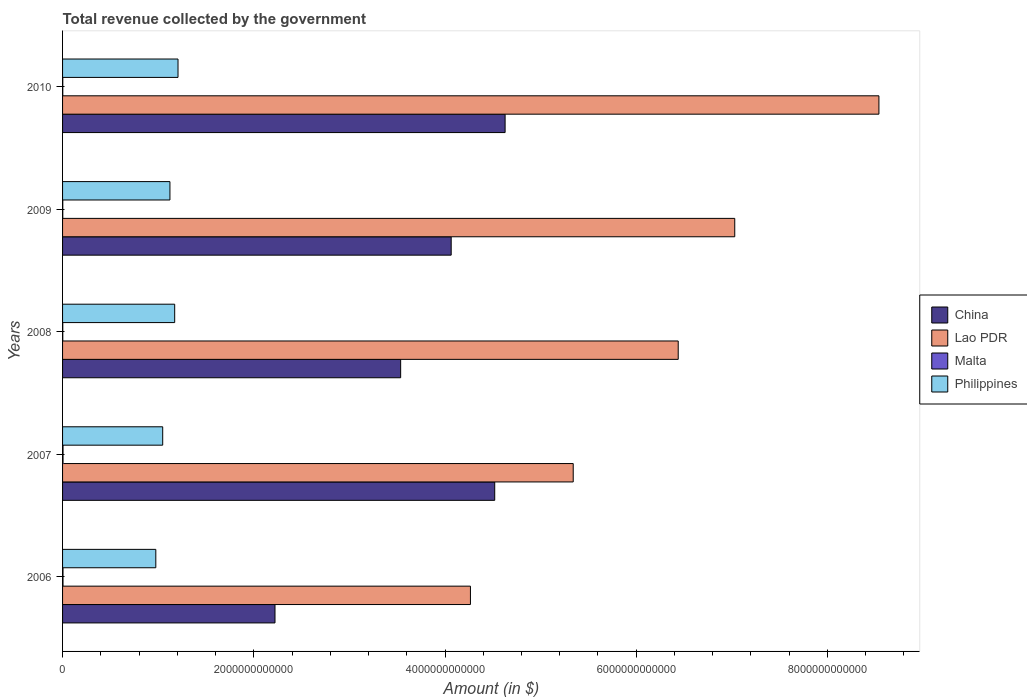How many different coloured bars are there?
Offer a very short reply. 4. How many groups of bars are there?
Offer a very short reply. 5. Are the number of bars on each tick of the Y-axis equal?
Provide a succinct answer. Yes. How many bars are there on the 2nd tick from the bottom?
Your answer should be compact. 4. What is the label of the 4th group of bars from the top?
Offer a terse response. 2007. What is the total revenue collected by the government in Philippines in 2007?
Give a very brief answer. 1.05e+12. Across all years, what is the maximum total revenue collected by the government in Lao PDR?
Ensure brevity in your answer.  8.54e+12. Across all years, what is the minimum total revenue collected by the government in Lao PDR?
Offer a very short reply. 4.27e+12. In which year was the total revenue collected by the government in Lao PDR maximum?
Provide a succinct answer. 2010. In which year was the total revenue collected by the government in Lao PDR minimum?
Make the answer very short. 2006. What is the total total revenue collected by the government in Philippines in the graph?
Your response must be concise. 5.53e+12. What is the difference between the total revenue collected by the government in Philippines in 2008 and that in 2010?
Offer a very short reply. -3.49e+1. What is the difference between the total revenue collected by the government in Malta in 2010 and the total revenue collected by the government in China in 2007?
Your response must be concise. -4.52e+12. What is the average total revenue collected by the government in Malta per year?
Provide a short and direct response. 3.25e+09. In the year 2007, what is the difference between the total revenue collected by the government in Malta and total revenue collected by the government in Lao PDR?
Ensure brevity in your answer.  -5.34e+12. What is the ratio of the total revenue collected by the government in Philippines in 2006 to that in 2007?
Provide a succinct answer. 0.93. What is the difference between the highest and the second highest total revenue collected by the government in China?
Ensure brevity in your answer.  1.09e+11. What is the difference between the highest and the lowest total revenue collected by the government in Malta?
Keep it short and to the point. 2.70e+09. Is the sum of the total revenue collected by the government in Philippines in 2007 and 2008 greater than the maximum total revenue collected by the government in China across all years?
Make the answer very short. No. Is it the case that in every year, the sum of the total revenue collected by the government in Malta and total revenue collected by the government in China is greater than the sum of total revenue collected by the government in Philippines and total revenue collected by the government in Lao PDR?
Make the answer very short. No. What does the 4th bar from the top in 2009 represents?
Give a very brief answer. China. What does the 3rd bar from the bottom in 2009 represents?
Keep it short and to the point. Malta. Is it the case that in every year, the sum of the total revenue collected by the government in Malta and total revenue collected by the government in China is greater than the total revenue collected by the government in Lao PDR?
Your answer should be compact. No. How many bars are there?
Give a very brief answer. 20. How many years are there in the graph?
Provide a short and direct response. 5. What is the difference between two consecutive major ticks on the X-axis?
Your answer should be very brief. 2.00e+12. Are the values on the major ticks of X-axis written in scientific E-notation?
Offer a terse response. No. Does the graph contain any zero values?
Give a very brief answer. No. Does the graph contain grids?
Your answer should be very brief. No. Where does the legend appear in the graph?
Offer a terse response. Center right. What is the title of the graph?
Offer a terse response. Total revenue collected by the government. What is the label or title of the X-axis?
Your response must be concise. Amount (in $). What is the label or title of the Y-axis?
Provide a succinct answer. Years. What is the Amount (in $) in China in 2006?
Your response must be concise. 2.22e+12. What is the Amount (in $) of Lao PDR in 2006?
Offer a terse response. 4.27e+12. What is the Amount (in $) in Malta in 2006?
Your response must be concise. 4.51e+09. What is the Amount (in $) of Philippines in 2006?
Your response must be concise. 9.75e+11. What is the Amount (in $) of China in 2007?
Your answer should be very brief. 4.52e+12. What is the Amount (in $) in Lao PDR in 2007?
Your answer should be very brief. 5.34e+12. What is the Amount (in $) in Malta in 2007?
Your response must be concise. 4.93e+09. What is the Amount (in $) of Philippines in 2007?
Ensure brevity in your answer.  1.05e+12. What is the Amount (in $) in China in 2008?
Offer a terse response. 3.54e+12. What is the Amount (in $) of Lao PDR in 2008?
Make the answer very short. 6.44e+12. What is the Amount (in $) in Malta in 2008?
Ensure brevity in your answer.  2.24e+09. What is the Amount (in $) in Philippines in 2008?
Your response must be concise. 1.17e+12. What is the Amount (in $) in China in 2009?
Your response must be concise. 4.06e+12. What is the Amount (in $) of Lao PDR in 2009?
Offer a terse response. 7.03e+12. What is the Amount (in $) of Malta in 2009?
Make the answer very short. 2.24e+09. What is the Amount (in $) of Philippines in 2009?
Keep it short and to the point. 1.12e+12. What is the Amount (in $) in China in 2010?
Provide a succinct answer. 4.63e+12. What is the Amount (in $) in Lao PDR in 2010?
Your answer should be very brief. 8.54e+12. What is the Amount (in $) in Malta in 2010?
Make the answer very short. 2.31e+09. What is the Amount (in $) in Philippines in 2010?
Provide a succinct answer. 1.21e+12. Across all years, what is the maximum Amount (in $) of China?
Your response must be concise. 4.63e+12. Across all years, what is the maximum Amount (in $) of Lao PDR?
Give a very brief answer. 8.54e+12. Across all years, what is the maximum Amount (in $) in Malta?
Offer a terse response. 4.93e+09. Across all years, what is the maximum Amount (in $) in Philippines?
Ensure brevity in your answer.  1.21e+12. Across all years, what is the minimum Amount (in $) in China?
Your response must be concise. 2.22e+12. Across all years, what is the minimum Amount (in $) of Lao PDR?
Provide a succinct answer. 4.27e+12. Across all years, what is the minimum Amount (in $) in Malta?
Keep it short and to the point. 2.24e+09. Across all years, what is the minimum Amount (in $) of Philippines?
Provide a succinct answer. 9.75e+11. What is the total Amount (in $) of China in the graph?
Provide a succinct answer. 1.90e+13. What is the total Amount (in $) in Lao PDR in the graph?
Your answer should be very brief. 3.16e+13. What is the total Amount (in $) in Malta in the graph?
Make the answer very short. 1.62e+1. What is the total Amount (in $) of Philippines in the graph?
Ensure brevity in your answer.  5.53e+12. What is the difference between the Amount (in $) of China in 2006 and that in 2007?
Provide a succinct answer. -2.30e+12. What is the difference between the Amount (in $) in Lao PDR in 2006 and that in 2007?
Keep it short and to the point. -1.07e+12. What is the difference between the Amount (in $) of Malta in 2006 and that in 2007?
Your response must be concise. -4.26e+08. What is the difference between the Amount (in $) in Philippines in 2006 and that in 2007?
Your answer should be very brief. -7.21e+1. What is the difference between the Amount (in $) in China in 2006 and that in 2008?
Make the answer very short. -1.31e+12. What is the difference between the Amount (in $) of Lao PDR in 2006 and that in 2008?
Your answer should be compact. -2.17e+12. What is the difference between the Amount (in $) in Malta in 2006 and that in 2008?
Give a very brief answer. 2.27e+09. What is the difference between the Amount (in $) in Philippines in 2006 and that in 2008?
Ensure brevity in your answer.  -1.97e+11. What is the difference between the Amount (in $) in China in 2006 and that in 2009?
Make the answer very short. -1.84e+12. What is the difference between the Amount (in $) in Lao PDR in 2006 and that in 2009?
Ensure brevity in your answer.  -2.76e+12. What is the difference between the Amount (in $) of Malta in 2006 and that in 2009?
Your answer should be compact. 2.27e+09. What is the difference between the Amount (in $) in Philippines in 2006 and that in 2009?
Make the answer very short. -1.48e+11. What is the difference between the Amount (in $) in China in 2006 and that in 2010?
Your answer should be very brief. -2.41e+12. What is the difference between the Amount (in $) in Lao PDR in 2006 and that in 2010?
Your answer should be very brief. -4.27e+12. What is the difference between the Amount (in $) of Malta in 2006 and that in 2010?
Make the answer very short. 2.20e+09. What is the difference between the Amount (in $) of Philippines in 2006 and that in 2010?
Provide a short and direct response. -2.32e+11. What is the difference between the Amount (in $) in China in 2007 and that in 2008?
Keep it short and to the point. 9.84e+11. What is the difference between the Amount (in $) of Lao PDR in 2007 and that in 2008?
Make the answer very short. -1.10e+12. What is the difference between the Amount (in $) in Malta in 2007 and that in 2008?
Your answer should be very brief. 2.69e+09. What is the difference between the Amount (in $) of Philippines in 2007 and that in 2008?
Give a very brief answer. -1.25e+11. What is the difference between the Amount (in $) of China in 2007 and that in 2009?
Provide a short and direct response. 4.55e+11. What is the difference between the Amount (in $) in Lao PDR in 2007 and that in 2009?
Offer a very short reply. -1.69e+12. What is the difference between the Amount (in $) in Malta in 2007 and that in 2009?
Your response must be concise. 2.70e+09. What is the difference between the Amount (in $) of Philippines in 2007 and that in 2009?
Make the answer very short. -7.56e+1. What is the difference between the Amount (in $) of China in 2007 and that in 2010?
Your response must be concise. -1.09e+11. What is the difference between the Amount (in $) of Lao PDR in 2007 and that in 2010?
Offer a very short reply. -3.20e+12. What is the difference between the Amount (in $) of Malta in 2007 and that in 2010?
Make the answer very short. 2.63e+09. What is the difference between the Amount (in $) of Philippines in 2007 and that in 2010?
Offer a terse response. -1.60e+11. What is the difference between the Amount (in $) in China in 2008 and that in 2009?
Your answer should be very brief. -5.29e+11. What is the difference between the Amount (in $) in Lao PDR in 2008 and that in 2009?
Provide a short and direct response. -5.91e+11. What is the difference between the Amount (in $) of Malta in 2008 and that in 2009?
Your answer should be very brief. 6.17e+06. What is the difference between the Amount (in $) in Philippines in 2008 and that in 2009?
Your answer should be compact. 4.97e+1. What is the difference between the Amount (in $) of China in 2008 and that in 2010?
Keep it short and to the point. -1.09e+12. What is the difference between the Amount (in $) of Lao PDR in 2008 and that in 2010?
Provide a short and direct response. -2.10e+12. What is the difference between the Amount (in $) in Malta in 2008 and that in 2010?
Provide a succinct answer. -6.30e+07. What is the difference between the Amount (in $) in Philippines in 2008 and that in 2010?
Ensure brevity in your answer.  -3.49e+1. What is the difference between the Amount (in $) of China in 2009 and that in 2010?
Your answer should be very brief. -5.64e+11. What is the difference between the Amount (in $) of Lao PDR in 2009 and that in 2010?
Offer a very short reply. -1.51e+12. What is the difference between the Amount (in $) of Malta in 2009 and that in 2010?
Your answer should be very brief. -6.92e+07. What is the difference between the Amount (in $) in Philippines in 2009 and that in 2010?
Give a very brief answer. -8.46e+1. What is the difference between the Amount (in $) of China in 2006 and the Amount (in $) of Lao PDR in 2007?
Provide a short and direct response. -3.12e+12. What is the difference between the Amount (in $) of China in 2006 and the Amount (in $) of Malta in 2007?
Offer a very short reply. 2.22e+12. What is the difference between the Amount (in $) in China in 2006 and the Amount (in $) in Philippines in 2007?
Provide a short and direct response. 1.17e+12. What is the difference between the Amount (in $) in Lao PDR in 2006 and the Amount (in $) in Malta in 2007?
Keep it short and to the point. 4.26e+12. What is the difference between the Amount (in $) in Lao PDR in 2006 and the Amount (in $) in Philippines in 2007?
Your answer should be very brief. 3.22e+12. What is the difference between the Amount (in $) in Malta in 2006 and the Amount (in $) in Philippines in 2007?
Your response must be concise. -1.04e+12. What is the difference between the Amount (in $) in China in 2006 and the Amount (in $) in Lao PDR in 2008?
Provide a succinct answer. -4.22e+12. What is the difference between the Amount (in $) of China in 2006 and the Amount (in $) of Malta in 2008?
Ensure brevity in your answer.  2.22e+12. What is the difference between the Amount (in $) of China in 2006 and the Amount (in $) of Philippines in 2008?
Ensure brevity in your answer.  1.05e+12. What is the difference between the Amount (in $) of Lao PDR in 2006 and the Amount (in $) of Malta in 2008?
Your answer should be compact. 4.26e+12. What is the difference between the Amount (in $) in Lao PDR in 2006 and the Amount (in $) in Philippines in 2008?
Your answer should be compact. 3.09e+12. What is the difference between the Amount (in $) in Malta in 2006 and the Amount (in $) in Philippines in 2008?
Your answer should be compact. -1.17e+12. What is the difference between the Amount (in $) in China in 2006 and the Amount (in $) in Lao PDR in 2009?
Your answer should be very brief. -4.81e+12. What is the difference between the Amount (in $) in China in 2006 and the Amount (in $) in Malta in 2009?
Provide a succinct answer. 2.22e+12. What is the difference between the Amount (in $) in China in 2006 and the Amount (in $) in Philippines in 2009?
Your response must be concise. 1.10e+12. What is the difference between the Amount (in $) in Lao PDR in 2006 and the Amount (in $) in Malta in 2009?
Provide a short and direct response. 4.26e+12. What is the difference between the Amount (in $) in Lao PDR in 2006 and the Amount (in $) in Philippines in 2009?
Give a very brief answer. 3.14e+12. What is the difference between the Amount (in $) of Malta in 2006 and the Amount (in $) of Philippines in 2009?
Offer a very short reply. -1.12e+12. What is the difference between the Amount (in $) of China in 2006 and the Amount (in $) of Lao PDR in 2010?
Your answer should be compact. -6.32e+12. What is the difference between the Amount (in $) of China in 2006 and the Amount (in $) of Malta in 2010?
Provide a succinct answer. 2.22e+12. What is the difference between the Amount (in $) in China in 2006 and the Amount (in $) in Philippines in 2010?
Offer a terse response. 1.01e+12. What is the difference between the Amount (in $) of Lao PDR in 2006 and the Amount (in $) of Malta in 2010?
Ensure brevity in your answer.  4.26e+12. What is the difference between the Amount (in $) in Lao PDR in 2006 and the Amount (in $) in Philippines in 2010?
Give a very brief answer. 3.06e+12. What is the difference between the Amount (in $) of Malta in 2006 and the Amount (in $) of Philippines in 2010?
Give a very brief answer. -1.20e+12. What is the difference between the Amount (in $) of China in 2007 and the Amount (in $) of Lao PDR in 2008?
Provide a succinct answer. -1.92e+12. What is the difference between the Amount (in $) in China in 2007 and the Amount (in $) in Malta in 2008?
Offer a terse response. 4.52e+12. What is the difference between the Amount (in $) of China in 2007 and the Amount (in $) of Philippines in 2008?
Give a very brief answer. 3.35e+12. What is the difference between the Amount (in $) in Lao PDR in 2007 and the Amount (in $) in Malta in 2008?
Offer a terse response. 5.34e+12. What is the difference between the Amount (in $) in Lao PDR in 2007 and the Amount (in $) in Philippines in 2008?
Your response must be concise. 4.17e+12. What is the difference between the Amount (in $) in Malta in 2007 and the Amount (in $) in Philippines in 2008?
Your response must be concise. -1.17e+12. What is the difference between the Amount (in $) of China in 2007 and the Amount (in $) of Lao PDR in 2009?
Keep it short and to the point. -2.51e+12. What is the difference between the Amount (in $) in China in 2007 and the Amount (in $) in Malta in 2009?
Your response must be concise. 4.52e+12. What is the difference between the Amount (in $) in China in 2007 and the Amount (in $) in Philippines in 2009?
Your response must be concise. 3.40e+12. What is the difference between the Amount (in $) in Lao PDR in 2007 and the Amount (in $) in Malta in 2009?
Ensure brevity in your answer.  5.34e+12. What is the difference between the Amount (in $) of Lao PDR in 2007 and the Amount (in $) of Philippines in 2009?
Make the answer very short. 4.22e+12. What is the difference between the Amount (in $) in Malta in 2007 and the Amount (in $) in Philippines in 2009?
Make the answer very short. -1.12e+12. What is the difference between the Amount (in $) in China in 2007 and the Amount (in $) in Lao PDR in 2010?
Your answer should be very brief. -4.02e+12. What is the difference between the Amount (in $) in China in 2007 and the Amount (in $) in Malta in 2010?
Give a very brief answer. 4.52e+12. What is the difference between the Amount (in $) in China in 2007 and the Amount (in $) in Philippines in 2010?
Make the answer very short. 3.31e+12. What is the difference between the Amount (in $) in Lao PDR in 2007 and the Amount (in $) in Malta in 2010?
Offer a terse response. 5.34e+12. What is the difference between the Amount (in $) in Lao PDR in 2007 and the Amount (in $) in Philippines in 2010?
Offer a terse response. 4.13e+12. What is the difference between the Amount (in $) of Malta in 2007 and the Amount (in $) of Philippines in 2010?
Your answer should be compact. -1.20e+12. What is the difference between the Amount (in $) in China in 2008 and the Amount (in $) in Lao PDR in 2009?
Your answer should be very brief. -3.49e+12. What is the difference between the Amount (in $) of China in 2008 and the Amount (in $) of Malta in 2009?
Offer a terse response. 3.53e+12. What is the difference between the Amount (in $) of China in 2008 and the Amount (in $) of Philippines in 2009?
Keep it short and to the point. 2.41e+12. What is the difference between the Amount (in $) of Lao PDR in 2008 and the Amount (in $) of Malta in 2009?
Your answer should be compact. 6.44e+12. What is the difference between the Amount (in $) in Lao PDR in 2008 and the Amount (in $) in Philippines in 2009?
Make the answer very short. 5.32e+12. What is the difference between the Amount (in $) in Malta in 2008 and the Amount (in $) in Philippines in 2009?
Offer a very short reply. -1.12e+12. What is the difference between the Amount (in $) in China in 2008 and the Amount (in $) in Lao PDR in 2010?
Offer a terse response. -5.00e+12. What is the difference between the Amount (in $) in China in 2008 and the Amount (in $) in Malta in 2010?
Your answer should be very brief. 3.53e+12. What is the difference between the Amount (in $) of China in 2008 and the Amount (in $) of Philippines in 2010?
Offer a terse response. 2.33e+12. What is the difference between the Amount (in $) of Lao PDR in 2008 and the Amount (in $) of Malta in 2010?
Make the answer very short. 6.44e+12. What is the difference between the Amount (in $) in Lao PDR in 2008 and the Amount (in $) in Philippines in 2010?
Your response must be concise. 5.23e+12. What is the difference between the Amount (in $) in Malta in 2008 and the Amount (in $) in Philippines in 2010?
Keep it short and to the point. -1.21e+12. What is the difference between the Amount (in $) of China in 2009 and the Amount (in $) of Lao PDR in 2010?
Make the answer very short. -4.47e+12. What is the difference between the Amount (in $) of China in 2009 and the Amount (in $) of Malta in 2010?
Keep it short and to the point. 4.06e+12. What is the difference between the Amount (in $) of China in 2009 and the Amount (in $) of Philippines in 2010?
Provide a succinct answer. 2.86e+12. What is the difference between the Amount (in $) in Lao PDR in 2009 and the Amount (in $) in Malta in 2010?
Offer a terse response. 7.03e+12. What is the difference between the Amount (in $) of Lao PDR in 2009 and the Amount (in $) of Philippines in 2010?
Your answer should be compact. 5.82e+12. What is the difference between the Amount (in $) in Malta in 2009 and the Amount (in $) in Philippines in 2010?
Provide a succinct answer. -1.21e+12. What is the average Amount (in $) of China per year?
Your answer should be compact. 3.79e+12. What is the average Amount (in $) of Lao PDR per year?
Offer a very short reply. 6.32e+12. What is the average Amount (in $) in Malta per year?
Make the answer very short. 3.25e+09. What is the average Amount (in $) of Philippines per year?
Your answer should be compact. 1.11e+12. In the year 2006, what is the difference between the Amount (in $) in China and Amount (in $) in Lao PDR?
Make the answer very short. -2.04e+12. In the year 2006, what is the difference between the Amount (in $) of China and Amount (in $) of Malta?
Ensure brevity in your answer.  2.22e+12. In the year 2006, what is the difference between the Amount (in $) of China and Amount (in $) of Philippines?
Your response must be concise. 1.25e+12. In the year 2006, what is the difference between the Amount (in $) of Lao PDR and Amount (in $) of Malta?
Your response must be concise. 4.26e+12. In the year 2006, what is the difference between the Amount (in $) of Lao PDR and Amount (in $) of Philippines?
Your answer should be compact. 3.29e+12. In the year 2006, what is the difference between the Amount (in $) of Malta and Amount (in $) of Philippines?
Provide a short and direct response. -9.71e+11. In the year 2007, what is the difference between the Amount (in $) in China and Amount (in $) in Lao PDR?
Provide a succinct answer. -8.21e+11. In the year 2007, what is the difference between the Amount (in $) in China and Amount (in $) in Malta?
Offer a very short reply. 4.51e+12. In the year 2007, what is the difference between the Amount (in $) in China and Amount (in $) in Philippines?
Keep it short and to the point. 3.47e+12. In the year 2007, what is the difference between the Amount (in $) of Lao PDR and Amount (in $) of Malta?
Keep it short and to the point. 5.34e+12. In the year 2007, what is the difference between the Amount (in $) of Lao PDR and Amount (in $) of Philippines?
Your answer should be compact. 4.29e+12. In the year 2007, what is the difference between the Amount (in $) in Malta and Amount (in $) in Philippines?
Give a very brief answer. -1.04e+12. In the year 2008, what is the difference between the Amount (in $) of China and Amount (in $) of Lao PDR?
Your answer should be very brief. -2.90e+12. In the year 2008, what is the difference between the Amount (in $) of China and Amount (in $) of Malta?
Provide a short and direct response. 3.53e+12. In the year 2008, what is the difference between the Amount (in $) of China and Amount (in $) of Philippines?
Provide a short and direct response. 2.36e+12. In the year 2008, what is the difference between the Amount (in $) of Lao PDR and Amount (in $) of Malta?
Provide a short and direct response. 6.44e+12. In the year 2008, what is the difference between the Amount (in $) of Lao PDR and Amount (in $) of Philippines?
Keep it short and to the point. 5.27e+12. In the year 2008, what is the difference between the Amount (in $) of Malta and Amount (in $) of Philippines?
Your answer should be very brief. -1.17e+12. In the year 2009, what is the difference between the Amount (in $) of China and Amount (in $) of Lao PDR?
Give a very brief answer. -2.97e+12. In the year 2009, what is the difference between the Amount (in $) in China and Amount (in $) in Malta?
Give a very brief answer. 4.06e+12. In the year 2009, what is the difference between the Amount (in $) in China and Amount (in $) in Philippines?
Your response must be concise. 2.94e+12. In the year 2009, what is the difference between the Amount (in $) in Lao PDR and Amount (in $) in Malta?
Make the answer very short. 7.03e+12. In the year 2009, what is the difference between the Amount (in $) of Lao PDR and Amount (in $) of Philippines?
Offer a very short reply. 5.91e+12. In the year 2009, what is the difference between the Amount (in $) of Malta and Amount (in $) of Philippines?
Your response must be concise. -1.12e+12. In the year 2010, what is the difference between the Amount (in $) in China and Amount (in $) in Lao PDR?
Your response must be concise. -3.91e+12. In the year 2010, what is the difference between the Amount (in $) in China and Amount (in $) in Malta?
Ensure brevity in your answer.  4.63e+12. In the year 2010, what is the difference between the Amount (in $) of China and Amount (in $) of Philippines?
Give a very brief answer. 3.42e+12. In the year 2010, what is the difference between the Amount (in $) in Lao PDR and Amount (in $) in Malta?
Provide a succinct answer. 8.54e+12. In the year 2010, what is the difference between the Amount (in $) of Lao PDR and Amount (in $) of Philippines?
Give a very brief answer. 7.33e+12. In the year 2010, what is the difference between the Amount (in $) in Malta and Amount (in $) in Philippines?
Provide a succinct answer. -1.21e+12. What is the ratio of the Amount (in $) of China in 2006 to that in 2007?
Your response must be concise. 0.49. What is the ratio of the Amount (in $) of Lao PDR in 2006 to that in 2007?
Your answer should be compact. 0.8. What is the ratio of the Amount (in $) of Malta in 2006 to that in 2007?
Your answer should be very brief. 0.91. What is the ratio of the Amount (in $) of Philippines in 2006 to that in 2007?
Provide a short and direct response. 0.93. What is the ratio of the Amount (in $) of China in 2006 to that in 2008?
Make the answer very short. 0.63. What is the ratio of the Amount (in $) of Lao PDR in 2006 to that in 2008?
Provide a succinct answer. 0.66. What is the ratio of the Amount (in $) in Malta in 2006 to that in 2008?
Keep it short and to the point. 2.01. What is the ratio of the Amount (in $) of Philippines in 2006 to that in 2008?
Ensure brevity in your answer.  0.83. What is the ratio of the Amount (in $) in China in 2006 to that in 2009?
Ensure brevity in your answer.  0.55. What is the ratio of the Amount (in $) in Lao PDR in 2006 to that in 2009?
Provide a succinct answer. 0.61. What is the ratio of the Amount (in $) in Malta in 2006 to that in 2009?
Ensure brevity in your answer.  2.02. What is the ratio of the Amount (in $) of Philippines in 2006 to that in 2009?
Provide a short and direct response. 0.87. What is the ratio of the Amount (in $) in China in 2006 to that in 2010?
Provide a short and direct response. 0.48. What is the ratio of the Amount (in $) of Lao PDR in 2006 to that in 2010?
Keep it short and to the point. 0.5. What is the ratio of the Amount (in $) in Malta in 2006 to that in 2010?
Your answer should be very brief. 1.96. What is the ratio of the Amount (in $) of Philippines in 2006 to that in 2010?
Provide a succinct answer. 0.81. What is the ratio of the Amount (in $) of China in 2007 to that in 2008?
Give a very brief answer. 1.28. What is the ratio of the Amount (in $) of Lao PDR in 2007 to that in 2008?
Ensure brevity in your answer.  0.83. What is the ratio of the Amount (in $) in Malta in 2007 to that in 2008?
Provide a short and direct response. 2.2. What is the ratio of the Amount (in $) of Philippines in 2007 to that in 2008?
Your answer should be compact. 0.89. What is the ratio of the Amount (in $) in China in 2007 to that in 2009?
Keep it short and to the point. 1.11. What is the ratio of the Amount (in $) in Lao PDR in 2007 to that in 2009?
Make the answer very short. 0.76. What is the ratio of the Amount (in $) of Malta in 2007 to that in 2009?
Your response must be concise. 2.21. What is the ratio of the Amount (in $) in Philippines in 2007 to that in 2009?
Give a very brief answer. 0.93. What is the ratio of the Amount (in $) of China in 2007 to that in 2010?
Offer a very short reply. 0.98. What is the ratio of the Amount (in $) of Lao PDR in 2007 to that in 2010?
Give a very brief answer. 0.63. What is the ratio of the Amount (in $) of Malta in 2007 to that in 2010?
Your response must be concise. 2.14. What is the ratio of the Amount (in $) of Philippines in 2007 to that in 2010?
Offer a very short reply. 0.87. What is the ratio of the Amount (in $) in China in 2008 to that in 2009?
Keep it short and to the point. 0.87. What is the ratio of the Amount (in $) of Lao PDR in 2008 to that in 2009?
Give a very brief answer. 0.92. What is the ratio of the Amount (in $) in Malta in 2008 to that in 2009?
Offer a very short reply. 1. What is the ratio of the Amount (in $) of Philippines in 2008 to that in 2009?
Your answer should be very brief. 1.04. What is the ratio of the Amount (in $) in China in 2008 to that in 2010?
Offer a very short reply. 0.76. What is the ratio of the Amount (in $) in Lao PDR in 2008 to that in 2010?
Offer a terse response. 0.75. What is the ratio of the Amount (in $) in Malta in 2008 to that in 2010?
Offer a very short reply. 0.97. What is the ratio of the Amount (in $) of Philippines in 2008 to that in 2010?
Offer a terse response. 0.97. What is the ratio of the Amount (in $) of China in 2009 to that in 2010?
Your answer should be compact. 0.88. What is the ratio of the Amount (in $) in Lao PDR in 2009 to that in 2010?
Your answer should be very brief. 0.82. What is the ratio of the Amount (in $) in Philippines in 2009 to that in 2010?
Provide a succinct answer. 0.93. What is the difference between the highest and the second highest Amount (in $) of China?
Make the answer very short. 1.09e+11. What is the difference between the highest and the second highest Amount (in $) in Lao PDR?
Keep it short and to the point. 1.51e+12. What is the difference between the highest and the second highest Amount (in $) in Malta?
Offer a very short reply. 4.26e+08. What is the difference between the highest and the second highest Amount (in $) in Philippines?
Provide a short and direct response. 3.49e+1. What is the difference between the highest and the lowest Amount (in $) of China?
Your answer should be very brief. 2.41e+12. What is the difference between the highest and the lowest Amount (in $) in Lao PDR?
Make the answer very short. 4.27e+12. What is the difference between the highest and the lowest Amount (in $) in Malta?
Ensure brevity in your answer.  2.70e+09. What is the difference between the highest and the lowest Amount (in $) in Philippines?
Ensure brevity in your answer.  2.32e+11. 